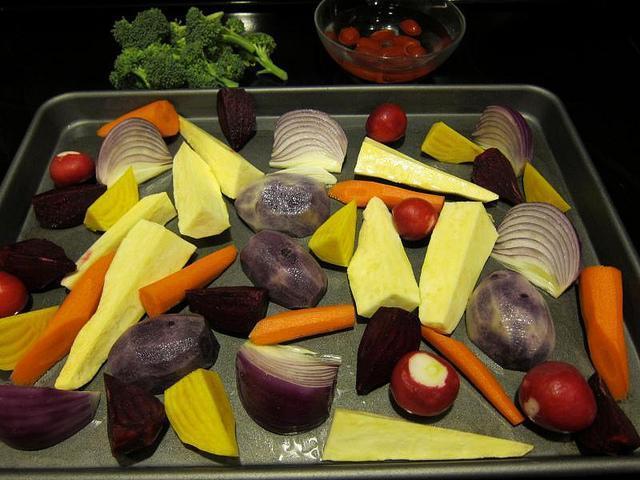How many carrots are in the picture?
Give a very brief answer. 6. 